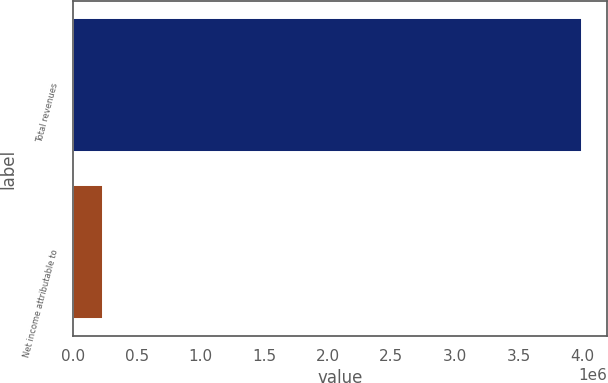<chart> <loc_0><loc_0><loc_500><loc_500><bar_chart><fcel>Total revenues<fcel>Net income attributable to<nl><fcel>3.99397e+06<fcel>234632<nl></chart> 